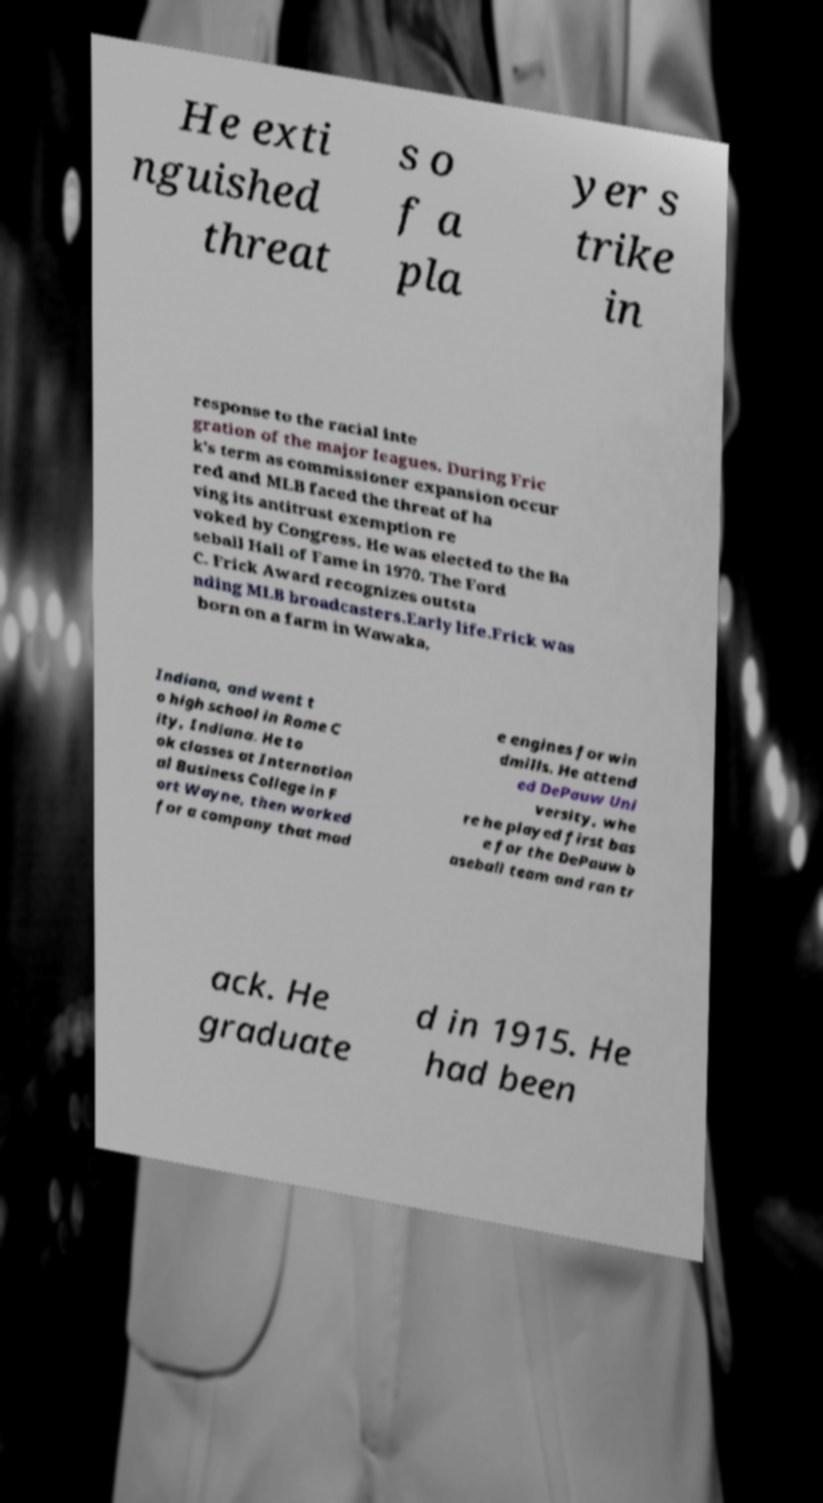What messages or text are displayed in this image? I need them in a readable, typed format. He exti nguished threat s o f a pla yer s trike in response to the racial inte gration of the major leagues. During Fric k's term as commissioner expansion occur red and MLB faced the threat of ha ving its antitrust exemption re voked by Congress. He was elected to the Ba seball Hall of Fame in 1970. The Ford C. Frick Award recognizes outsta nding MLB broadcasters.Early life.Frick was born on a farm in Wawaka, Indiana, and went t o high school in Rome C ity, Indiana. He to ok classes at Internation al Business College in F ort Wayne, then worked for a company that mad e engines for win dmills. He attend ed DePauw Uni versity, whe re he played first bas e for the DePauw b aseball team and ran tr ack. He graduate d in 1915. He had been 